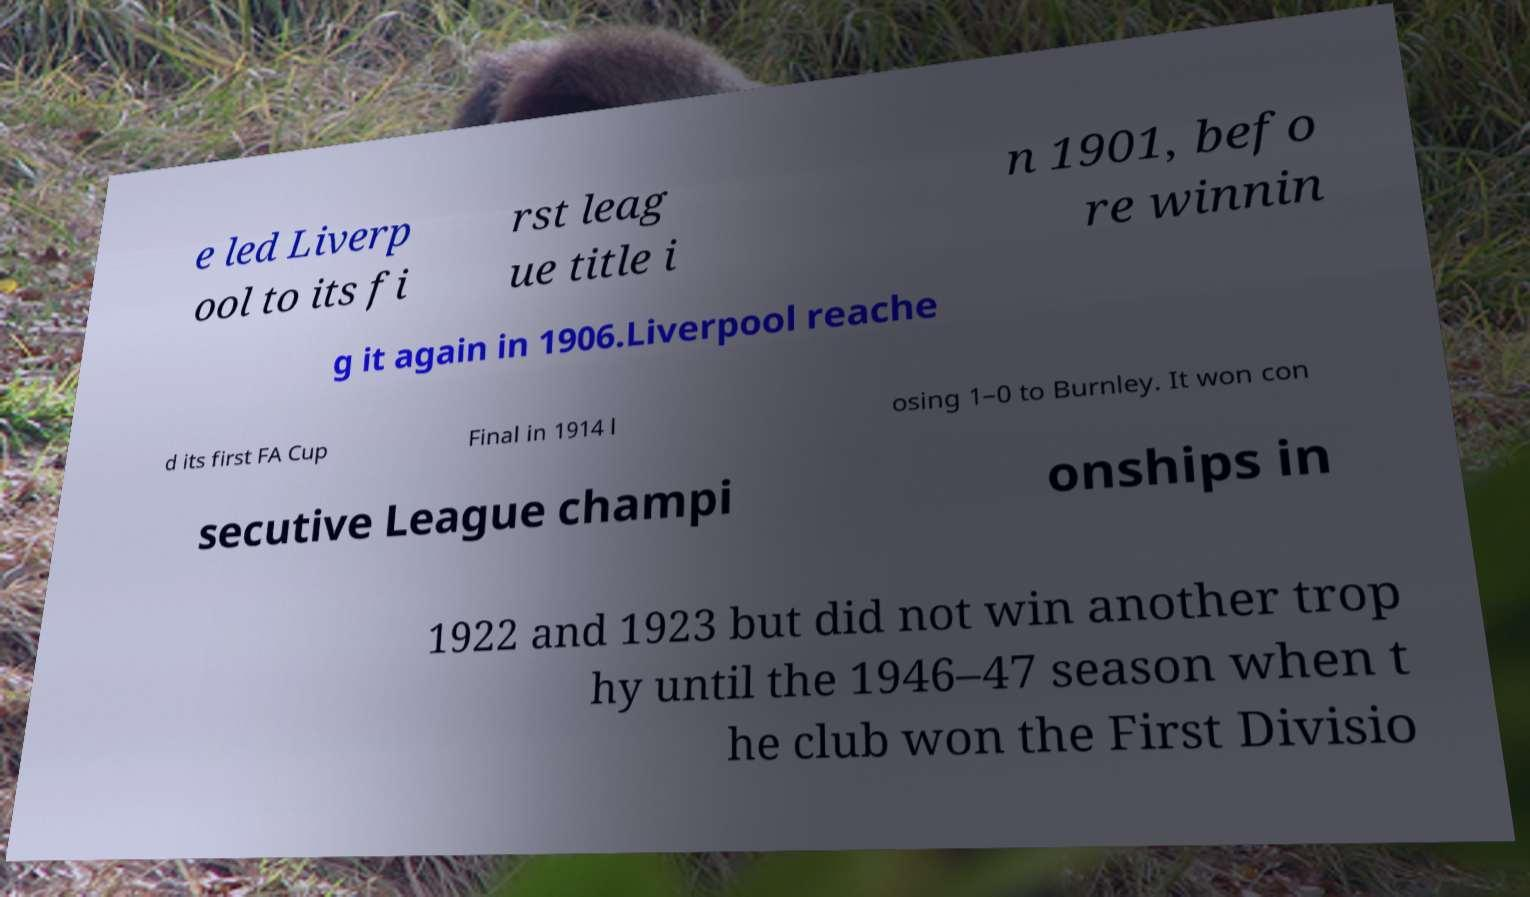Can you read and provide the text displayed in the image?This photo seems to have some interesting text. Can you extract and type it out for me? e led Liverp ool to its fi rst leag ue title i n 1901, befo re winnin g it again in 1906.Liverpool reache d its first FA Cup Final in 1914 l osing 1–0 to Burnley. It won con secutive League champi onships in 1922 and 1923 but did not win another trop hy until the 1946–47 season when t he club won the First Divisio 